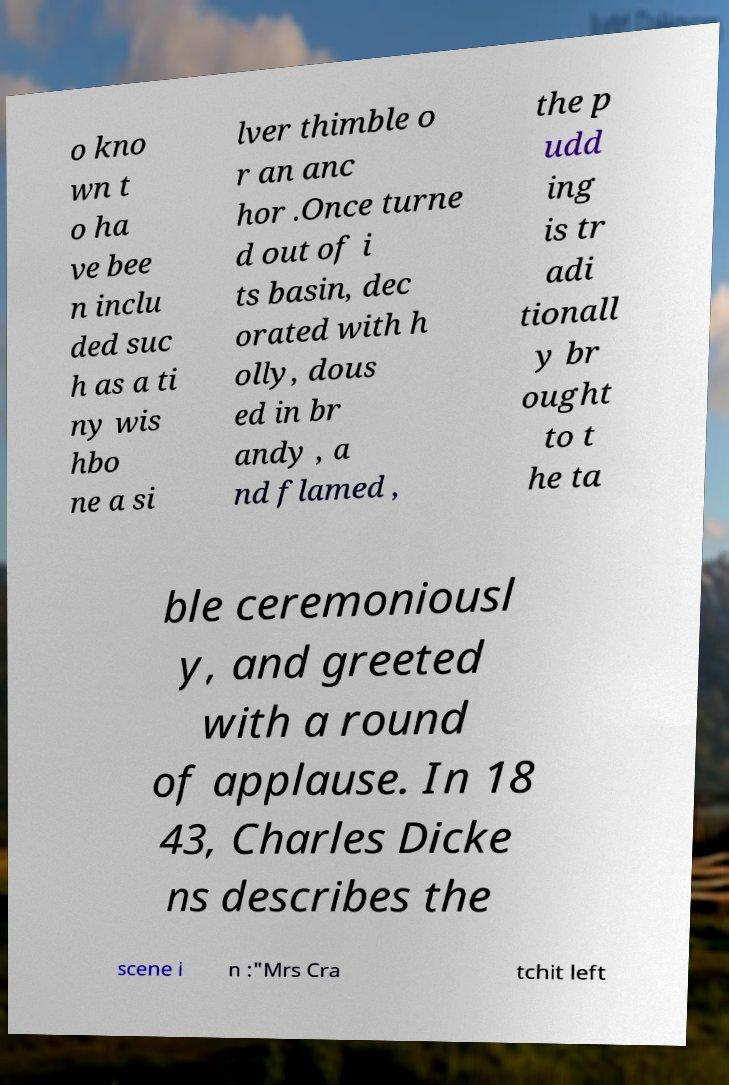Please identify and transcribe the text found in this image. o kno wn t o ha ve bee n inclu ded suc h as a ti ny wis hbo ne a si lver thimble o r an anc hor .Once turne d out of i ts basin, dec orated with h olly, dous ed in br andy , a nd flamed , the p udd ing is tr adi tionall y br ought to t he ta ble ceremoniousl y, and greeted with a round of applause. In 18 43, Charles Dicke ns describes the scene i n :"Mrs Cra tchit left 